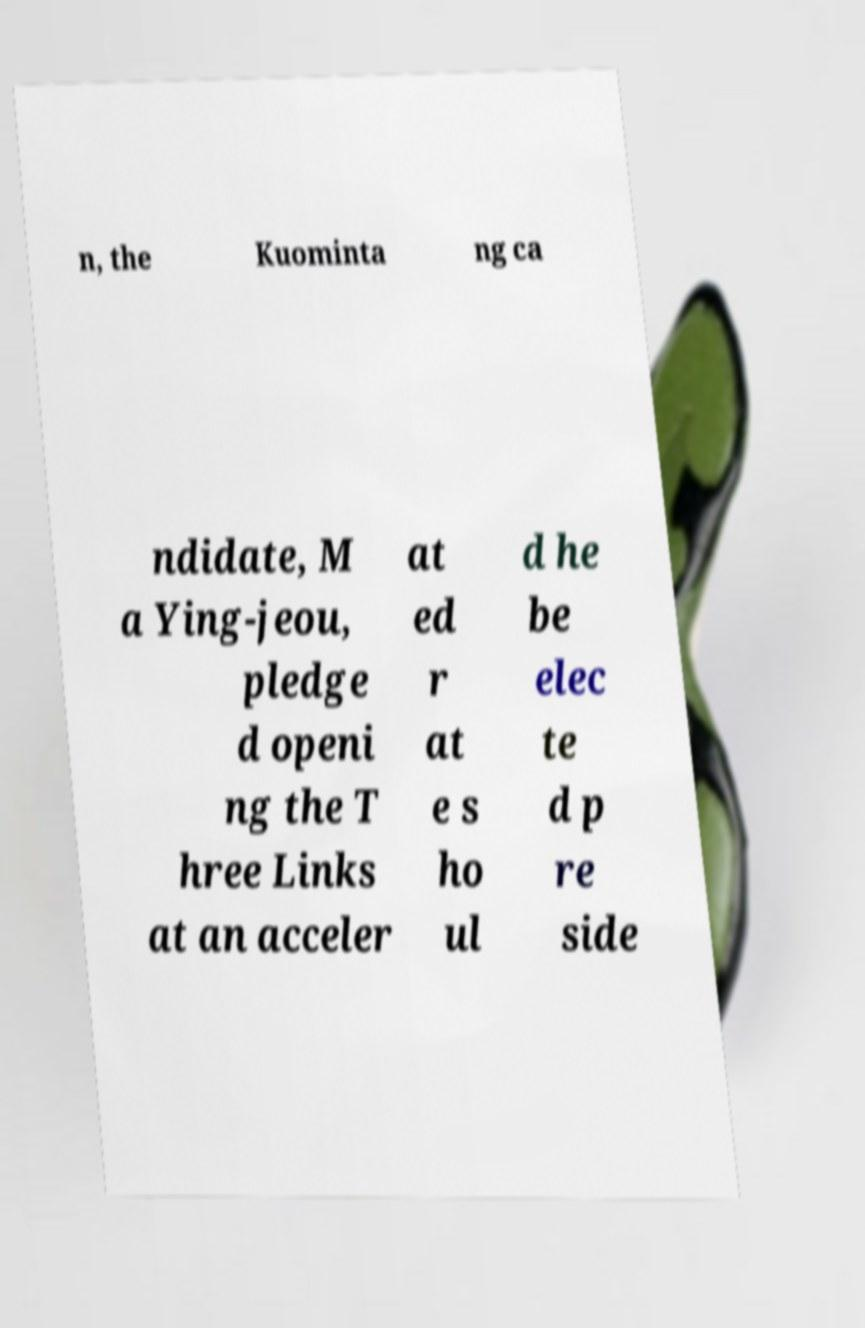I need the written content from this picture converted into text. Can you do that? n, the Kuominta ng ca ndidate, M a Ying-jeou, pledge d openi ng the T hree Links at an acceler at ed r at e s ho ul d he be elec te d p re side 